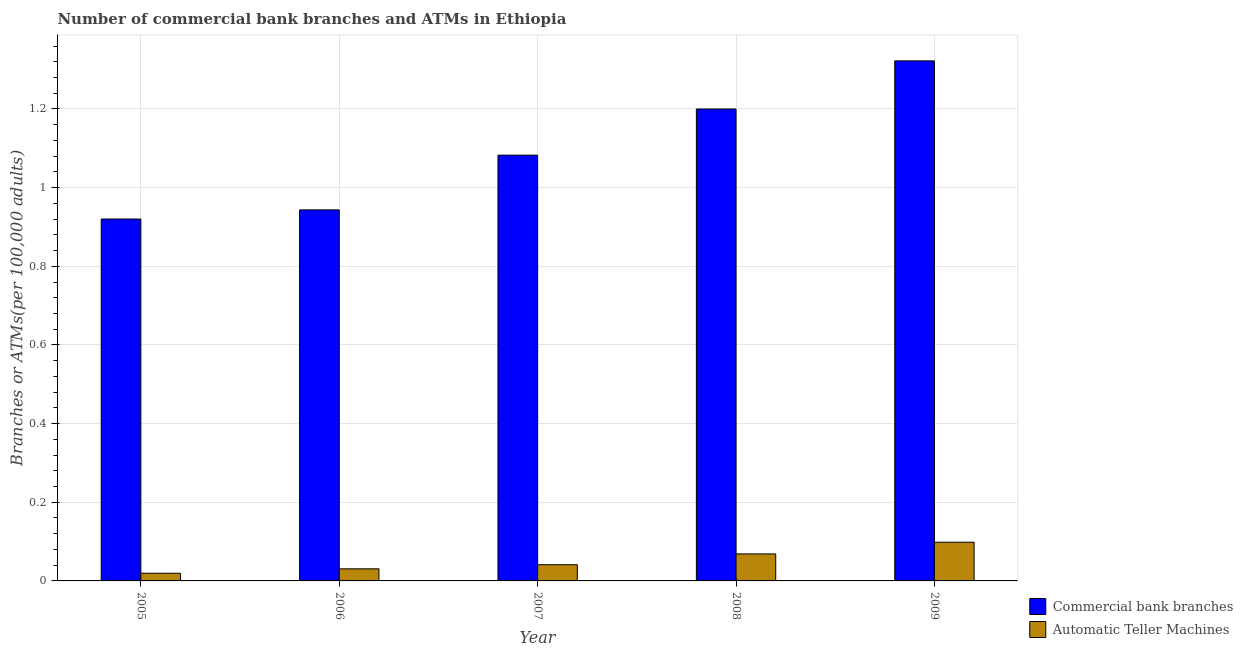How many groups of bars are there?
Your response must be concise. 5. How many bars are there on the 5th tick from the left?
Provide a short and direct response. 2. How many bars are there on the 2nd tick from the right?
Provide a succinct answer. 2. What is the label of the 1st group of bars from the left?
Keep it short and to the point. 2005. What is the number of commercal bank branches in 2006?
Provide a succinct answer. 0.94. Across all years, what is the maximum number of commercal bank branches?
Your response must be concise. 1.32. Across all years, what is the minimum number of atms?
Offer a terse response. 0.02. What is the total number of commercal bank branches in the graph?
Your answer should be compact. 5.47. What is the difference between the number of commercal bank branches in 2005 and that in 2007?
Ensure brevity in your answer.  -0.16. What is the difference between the number of commercal bank branches in 2009 and the number of atms in 2008?
Ensure brevity in your answer.  0.12. What is the average number of commercal bank branches per year?
Keep it short and to the point. 1.09. What is the ratio of the number of commercal bank branches in 2006 to that in 2008?
Provide a short and direct response. 0.79. Is the difference between the number of atms in 2006 and 2009 greater than the difference between the number of commercal bank branches in 2006 and 2009?
Ensure brevity in your answer.  No. What is the difference between the highest and the second highest number of commercal bank branches?
Offer a very short reply. 0.12. What is the difference between the highest and the lowest number of commercal bank branches?
Ensure brevity in your answer.  0.4. What does the 1st bar from the left in 2008 represents?
Give a very brief answer. Commercial bank branches. What does the 2nd bar from the right in 2006 represents?
Make the answer very short. Commercial bank branches. Are all the bars in the graph horizontal?
Your response must be concise. No. How many years are there in the graph?
Your answer should be very brief. 5. What is the difference between two consecutive major ticks on the Y-axis?
Provide a short and direct response. 0.2. Does the graph contain any zero values?
Provide a succinct answer. No. Does the graph contain grids?
Your answer should be very brief. Yes. Where does the legend appear in the graph?
Your answer should be compact. Bottom right. How many legend labels are there?
Make the answer very short. 2. How are the legend labels stacked?
Provide a short and direct response. Vertical. What is the title of the graph?
Keep it short and to the point. Number of commercial bank branches and ATMs in Ethiopia. What is the label or title of the Y-axis?
Offer a terse response. Branches or ATMs(per 100,0 adults). What is the Branches or ATMs(per 100,000 adults) of Commercial bank branches in 2005?
Give a very brief answer. 0.92. What is the Branches or ATMs(per 100,000 adults) of Automatic Teller Machines in 2005?
Provide a short and direct response. 0.02. What is the Branches or ATMs(per 100,000 adults) in Commercial bank branches in 2006?
Offer a very short reply. 0.94. What is the Branches or ATMs(per 100,000 adults) in Automatic Teller Machines in 2006?
Offer a terse response. 0.03. What is the Branches or ATMs(per 100,000 adults) in Commercial bank branches in 2007?
Offer a terse response. 1.08. What is the Branches or ATMs(per 100,000 adults) in Automatic Teller Machines in 2007?
Your answer should be very brief. 0.04. What is the Branches or ATMs(per 100,000 adults) in Commercial bank branches in 2008?
Offer a terse response. 1.2. What is the Branches or ATMs(per 100,000 adults) in Automatic Teller Machines in 2008?
Your response must be concise. 0.07. What is the Branches or ATMs(per 100,000 adults) of Commercial bank branches in 2009?
Your response must be concise. 1.32. What is the Branches or ATMs(per 100,000 adults) of Automatic Teller Machines in 2009?
Your answer should be very brief. 0.1. Across all years, what is the maximum Branches or ATMs(per 100,000 adults) of Commercial bank branches?
Provide a short and direct response. 1.32. Across all years, what is the maximum Branches or ATMs(per 100,000 adults) of Automatic Teller Machines?
Your answer should be compact. 0.1. Across all years, what is the minimum Branches or ATMs(per 100,000 adults) in Commercial bank branches?
Offer a terse response. 0.92. Across all years, what is the minimum Branches or ATMs(per 100,000 adults) of Automatic Teller Machines?
Offer a terse response. 0.02. What is the total Branches or ATMs(per 100,000 adults) of Commercial bank branches in the graph?
Your answer should be compact. 5.47. What is the total Branches or ATMs(per 100,000 adults) of Automatic Teller Machines in the graph?
Give a very brief answer. 0.26. What is the difference between the Branches or ATMs(per 100,000 adults) in Commercial bank branches in 2005 and that in 2006?
Keep it short and to the point. -0.02. What is the difference between the Branches or ATMs(per 100,000 adults) of Automatic Teller Machines in 2005 and that in 2006?
Offer a terse response. -0.01. What is the difference between the Branches or ATMs(per 100,000 adults) in Commercial bank branches in 2005 and that in 2007?
Keep it short and to the point. -0.16. What is the difference between the Branches or ATMs(per 100,000 adults) in Automatic Teller Machines in 2005 and that in 2007?
Keep it short and to the point. -0.02. What is the difference between the Branches or ATMs(per 100,000 adults) of Commercial bank branches in 2005 and that in 2008?
Your answer should be compact. -0.28. What is the difference between the Branches or ATMs(per 100,000 adults) in Automatic Teller Machines in 2005 and that in 2008?
Provide a succinct answer. -0.05. What is the difference between the Branches or ATMs(per 100,000 adults) in Commercial bank branches in 2005 and that in 2009?
Provide a succinct answer. -0.4. What is the difference between the Branches or ATMs(per 100,000 adults) in Automatic Teller Machines in 2005 and that in 2009?
Your answer should be compact. -0.08. What is the difference between the Branches or ATMs(per 100,000 adults) of Commercial bank branches in 2006 and that in 2007?
Offer a terse response. -0.14. What is the difference between the Branches or ATMs(per 100,000 adults) of Automatic Teller Machines in 2006 and that in 2007?
Make the answer very short. -0.01. What is the difference between the Branches or ATMs(per 100,000 adults) in Commercial bank branches in 2006 and that in 2008?
Keep it short and to the point. -0.26. What is the difference between the Branches or ATMs(per 100,000 adults) of Automatic Teller Machines in 2006 and that in 2008?
Your answer should be very brief. -0.04. What is the difference between the Branches or ATMs(per 100,000 adults) of Commercial bank branches in 2006 and that in 2009?
Offer a very short reply. -0.38. What is the difference between the Branches or ATMs(per 100,000 adults) of Automatic Teller Machines in 2006 and that in 2009?
Your answer should be compact. -0.07. What is the difference between the Branches or ATMs(per 100,000 adults) in Commercial bank branches in 2007 and that in 2008?
Provide a short and direct response. -0.12. What is the difference between the Branches or ATMs(per 100,000 adults) in Automatic Teller Machines in 2007 and that in 2008?
Keep it short and to the point. -0.03. What is the difference between the Branches or ATMs(per 100,000 adults) in Commercial bank branches in 2007 and that in 2009?
Offer a very short reply. -0.24. What is the difference between the Branches or ATMs(per 100,000 adults) of Automatic Teller Machines in 2007 and that in 2009?
Offer a terse response. -0.06. What is the difference between the Branches or ATMs(per 100,000 adults) of Commercial bank branches in 2008 and that in 2009?
Your response must be concise. -0.12. What is the difference between the Branches or ATMs(per 100,000 adults) in Automatic Teller Machines in 2008 and that in 2009?
Provide a short and direct response. -0.03. What is the difference between the Branches or ATMs(per 100,000 adults) of Commercial bank branches in 2005 and the Branches or ATMs(per 100,000 adults) of Automatic Teller Machines in 2006?
Keep it short and to the point. 0.89. What is the difference between the Branches or ATMs(per 100,000 adults) in Commercial bank branches in 2005 and the Branches or ATMs(per 100,000 adults) in Automatic Teller Machines in 2007?
Offer a very short reply. 0.88. What is the difference between the Branches or ATMs(per 100,000 adults) in Commercial bank branches in 2005 and the Branches or ATMs(per 100,000 adults) in Automatic Teller Machines in 2008?
Offer a terse response. 0.85. What is the difference between the Branches or ATMs(per 100,000 adults) in Commercial bank branches in 2005 and the Branches or ATMs(per 100,000 adults) in Automatic Teller Machines in 2009?
Offer a terse response. 0.82. What is the difference between the Branches or ATMs(per 100,000 adults) of Commercial bank branches in 2006 and the Branches or ATMs(per 100,000 adults) of Automatic Teller Machines in 2007?
Offer a terse response. 0.9. What is the difference between the Branches or ATMs(per 100,000 adults) in Commercial bank branches in 2006 and the Branches or ATMs(per 100,000 adults) in Automatic Teller Machines in 2008?
Your answer should be very brief. 0.87. What is the difference between the Branches or ATMs(per 100,000 adults) in Commercial bank branches in 2006 and the Branches or ATMs(per 100,000 adults) in Automatic Teller Machines in 2009?
Your answer should be compact. 0.84. What is the difference between the Branches or ATMs(per 100,000 adults) of Commercial bank branches in 2007 and the Branches or ATMs(per 100,000 adults) of Automatic Teller Machines in 2009?
Ensure brevity in your answer.  0.98. What is the difference between the Branches or ATMs(per 100,000 adults) in Commercial bank branches in 2008 and the Branches or ATMs(per 100,000 adults) in Automatic Teller Machines in 2009?
Your answer should be compact. 1.1. What is the average Branches or ATMs(per 100,000 adults) in Commercial bank branches per year?
Ensure brevity in your answer.  1.09. What is the average Branches or ATMs(per 100,000 adults) in Automatic Teller Machines per year?
Offer a very short reply. 0.05. In the year 2005, what is the difference between the Branches or ATMs(per 100,000 adults) of Commercial bank branches and Branches or ATMs(per 100,000 adults) of Automatic Teller Machines?
Keep it short and to the point. 0.9. In the year 2006, what is the difference between the Branches or ATMs(per 100,000 adults) in Commercial bank branches and Branches or ATMs(per 100,000 adults) in Automatic Teller Machines?
Offer a terse response. 0.91. In the year 2007, what is the difference between the Branches or ATMs(per 100,000 adults) of Commercial bank branches and Branches or ATMs(per 100,000 adults) of Automatic Teller Machines?
Your response must be concise. 1.04. In the year 2008, what is the difference between the Branches or ATMs(per 100,000 adults) of Commercial bank branches and Branches or ATMs(per 100,000 adults) of Automatic Teller Machines?
Your response must be concise. 1.13. In the year 2009, what is the difference between the Branches or ATMs(per 100,000 adults) of Commercial bank branches and Branches or ATMs(per 100,000 adults) of Automatic Teller Machines?
Provide a succinct answer. 1.22. What is the ratio of the Branches or ATMs(per 100,000 adults) of Commercial bank branches in 2005 to that in 2006?
Offer a terse response. 0.98. What is the ratio of the Branches or ATMs(per 100,000 adults) in Automatic Teller Machines in 2005 to that in 2006?
Provide a short and direct response. 0.64. What is the ratio of the Branches or ATMs(per 100,000 adults) of Automatic Teller Machines in 2005 to that in 2007?
Provide a succinct answer. 0.47. What is the ratio of the Branches or ATMs(per 100,000 adults) of Commercial bank branches in 2005 to that in 2008?
Your answer should be very brief. 0.77. What is the ratio of the Branches or ATMs(per 100,000 adults) of Automatic Teller Machines in 2005 to that in 2008?
Make the answer very short. 0.28. What is the ratio of the Branches or ATMs(per 100,000 adults) in Commercial bank branches in 2005 to that in 2009?
Provide a succinct answer. 0.7. What is the ratio of the Branches or ATMs(per 100,000 adults) in Automatic Teller Machines in 2005 to that in 2009?
Your answer should be compact. 0.2. What is the ratio of the Branches or ATMs(per 100,000 adults) in Commercial bank branches in 2006 to that in 2007?
Give a very brief answer. 0.87. What is the ratio of the Branches or ATMs(per 100,000 adults) of Automatic Teller Machines in 2006 to that in 2007?
Give a very brief answer. 0.75. What is the ratio of the Branches or ATMs(per 100,000 adults) of Commercial bank branches in 2006 to that in 2008?
Provide a short and direct response. 0.79. What is the ratio of the Branches or ATMs(per 100,000 adults) in Automatic Teller Machines in 2006 to that in 2008?
Ensure brevity in your answer.  0.45. What is the ratio of the Branches or ATMs(per 100,000 adults) in Commercial bank branches in 2006 to that in 2009?
Offer a very short reply. 0.71. What is the ratio of the Branches or ATMs(per 100,000 adults) in Automatic Teller Machines in 2006 to that in 2009?
Your answer should be compact. 0.31. What is the ratio of the Branches or ATMs(per 100,000 adults) in Commercial bank branches in 2007 to that in 2008?
Keep it short and to the point. 0.9. What is the ratio of the Branches or ATMs(per 100,000 adults) of Automatic Teller Machines in 2007 to that in 2008?
Give a very brief answer. 0.6. What is the ratio of the Branches or ATMs(per 100,000 adults) of Commercial bank branches in 2007 to that in 2009?
Offer a terse response. 0.82. What is the ratio of the Branches or ATMs(per 100,000 adults) of Automatic Teller Machines in 2007 to that in 2009?
Your answer should be very brief. 0.42. What is the ratio of the Branches or ATMs(per 100,000 adults) in Commercial bank branches in 2008 to that in 2009?
Keep it short and to the point. 0.91. What is the ratio of the Branches or ATMs(per 100,000 adults) in Automatic Teller Machines in 2008 to that in 2009?
Provide a succinct answer. 0.7. What is the difference between the highest and the second highest Branches or ATMs(per 100,000 adults) of Commercial bank branches?
Keep it short and to the point. 0.12. What is the difference between the highest and the second highest Branches or ATMs(per 100,000 adults) in Automatic Teller Machines?
Make the answer very short. 0.03. What is the difference between the highest and the lowest Branches or ATMs(per 100,000 adults) in Commercial bank branches?
Provide a short and direct response. 0.4. What is the difference between the highest and the lowest Branches or ATMs(per 100,000 adults) in Automatic Teller Machines?
Keep it short and to the point. 0.08. 